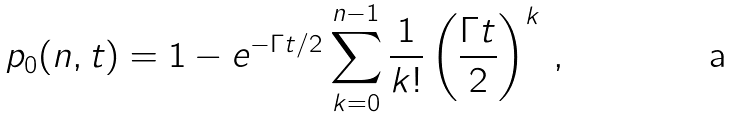<formula> <loc_0><loc_0><loc_500><loc_500>p _ { 0 } ( n , t ) = 1 - e ^ { - \Gamma t / 2 } \sum _ { k = 0 } ^ { n - 1 } \frac { 1 } { k ! } \left ( \frac { \Gamma t } { 2 } \right ) ^ { k } \, ,</formula> 